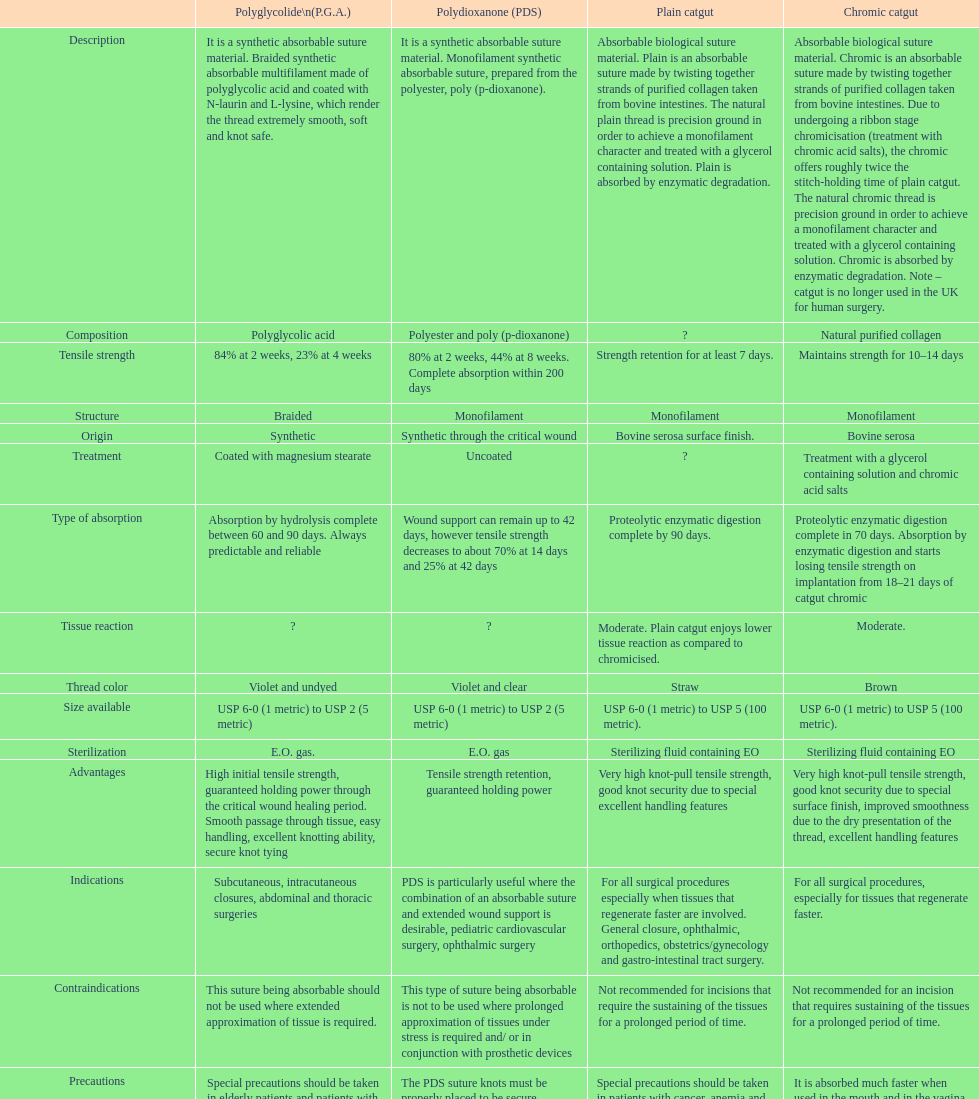What is the duration that a chromic catgut retains its strength? 10-14 days. 